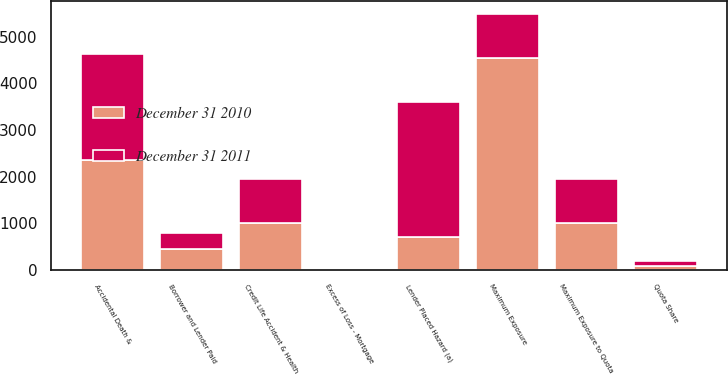<chart> <loc_0><loc_0><loc_500><loc_500><stacked_bar_chart><ecel><fcel>Accidental Death &<fcel>Credit Life Accident & Health<fcel>Lender Placed Hazard (a)<fcel>Borrower and Lender Paid<fcel>Maximum Exposure<fcel>Excess of Loss - Mortgage<fcel>Quota Share<fcel>Maximum Exposure to Quota<nl><fcel>December 31 2011<fcel>2255<fcel>951<fcel>2899<fcel>327<fcel>950<fcel>4<fcel>96<fcel>950<nl><fcel>December 31 2010<fcel>2367<fcel>1003<fcel>709<fcel>463<fcel>4542<fcel>8<fcel>92<fcel>1001<nl></chart> 